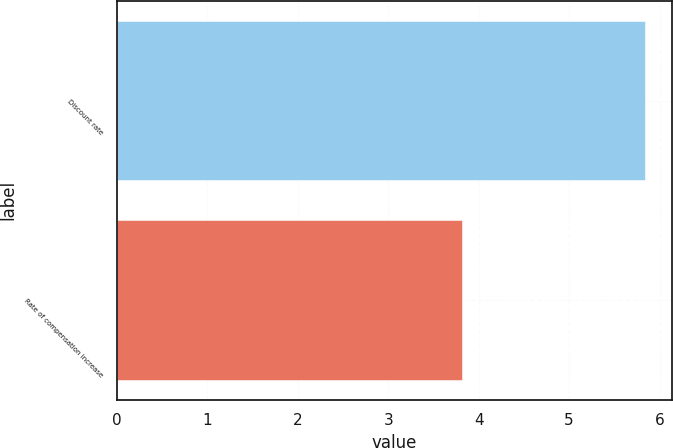<chart> <loc_0><loc_0><loc_500><loc_500><bar_chart><fcel>Discount rate<fcel>Rate of compensation increase<nl><fcel>5.84<fcel>3.82<nl></chart> 